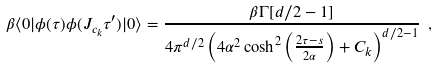<formula> <loc_0><loc_0><loc_500><loc_500>\beta \langle { 0 } | \phi ( \tau ) \phi ( J _ { c _ { k } } \tau ^ { \prime } ) | 0 \rangle = \frac { \beta \Gamma [ d / 2 - 1 ] } { 4 \pi ^ { d / 2 } \left ( 4 \alpha ^ { 2 } \cosh ^ { 2 } \left ( \frac { 2 \tau - s } { 2 \alpha } \right ) + C _ { k } \right ) ^ { d / 2 - 1 } } \ ,</formula> 